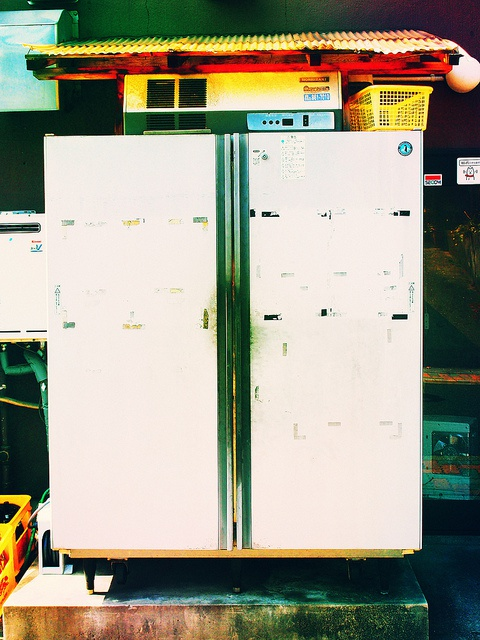Describe the objects in this image and their specific colors. I can see a refrigerator in darkgreen, white, black, and darkgray tones in this image. 